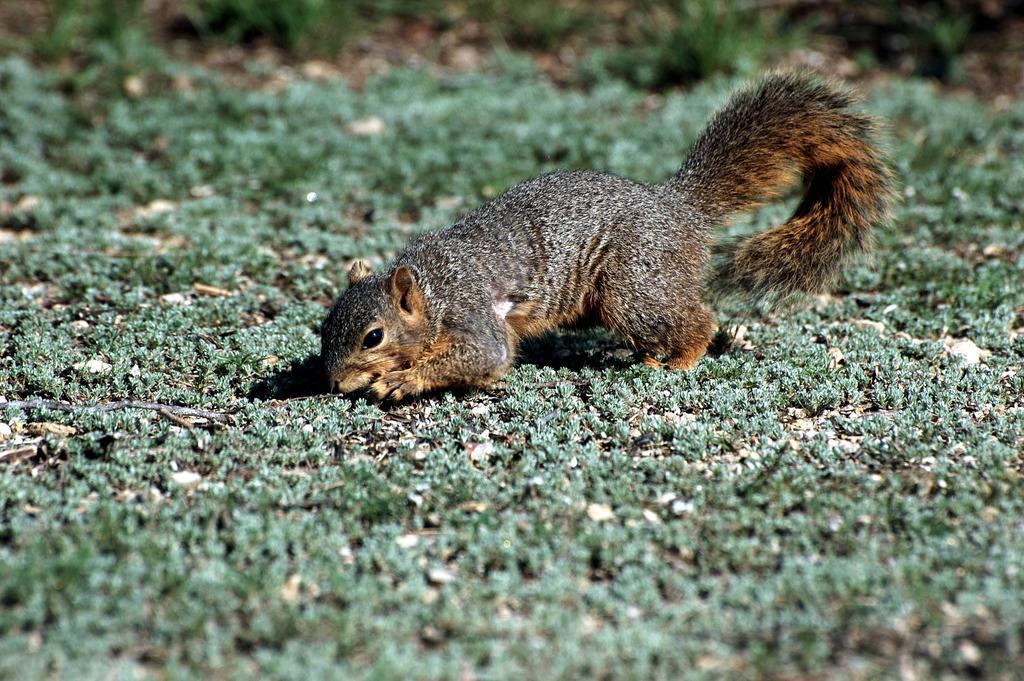Could you give a brief overview of what you see in this image? In the picture there is a squirrel laying on a grass surface. 